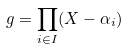<formula> <loc_0><loc_0><loc_500><loc_500>g = \prod _ { i \in I } ( X - \alpha _ { i } )</formula> 